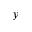Convert formula to latex. <formula><loc_0><loc_0><loc_500><loc_500>y</formula> 